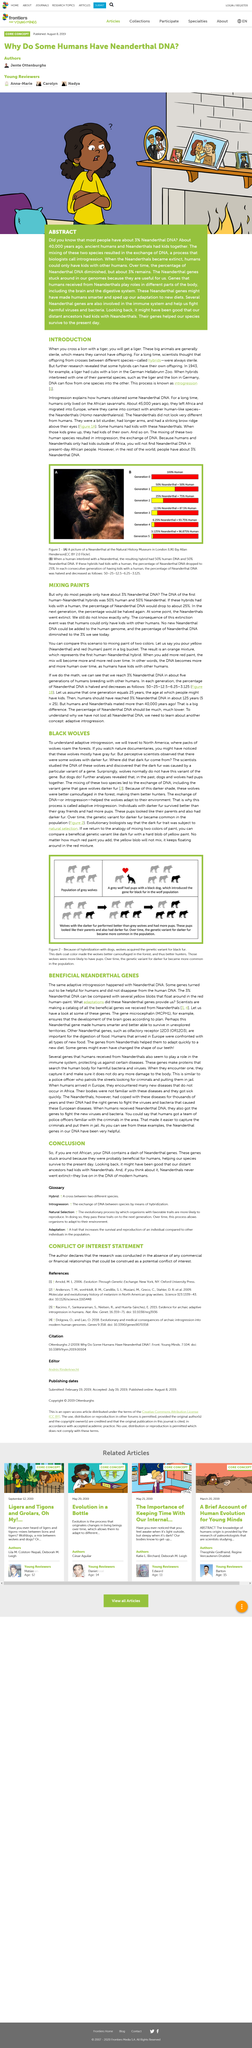Give some essential details in this illustration. It is a commonly held belief that wolves have crossed with dogs, resulting in the domestication of the animal now known as the dog. It is not possible to find Neanderthal DNA in the DNA of present-day African people. I declare that sterile means the inability to produce offspring. Orange is the color that results from mixing red and yellow. According to the article "MIXING PAINTS," the majority of people have 3% Neanderthal DNA. 